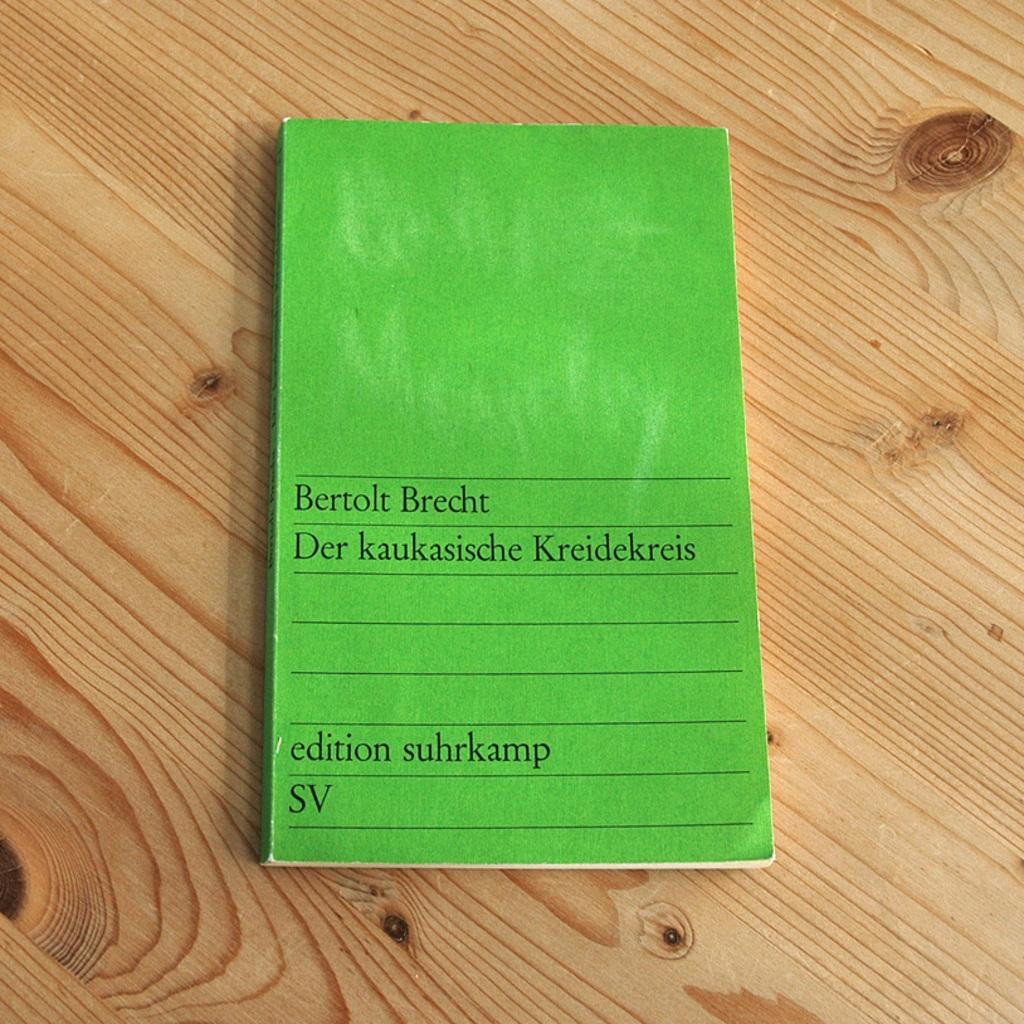<image>
Give a short and clear explanation of the subsequent image. A small green notepad Bertolt Brecht on a wood surface. 